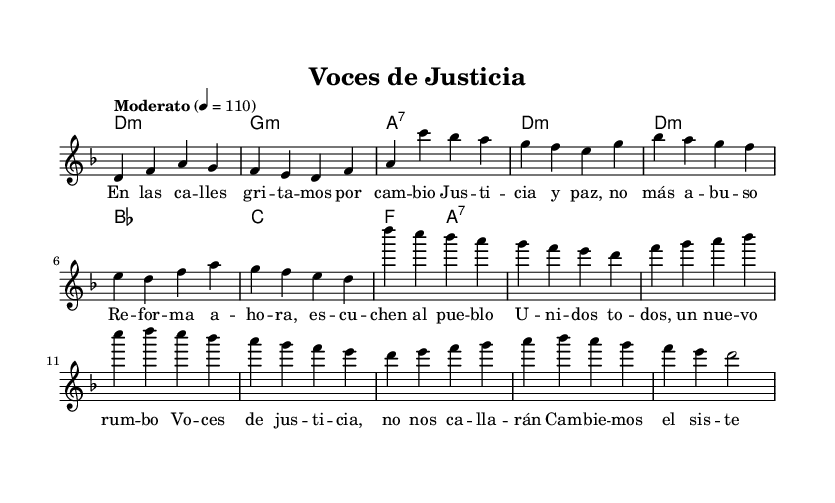What is the key signature of this music? The key signature is indicated at the beginning of the piece, which shows two flats, indicating that the piece is in D minor.
Answer: D minor What is the time signature of this music? The time signature is located right after the key signature, showing a 4/4 notation, which indicates that there are four beats in a measure.
Answer: 4/4 What is the tempo marking of this piece? The tempo notation appears in the score, which specifies "Moderato" at a speed of 4 = 110, indicating a moderate pace for the music.
Answer: Moderato How many measures are there in the verse? The verse consists of four lines of music, each containing four measures, so the total is 4 measures in the verse.
Answer: 16 What is the theme of the lyrics in the chorus? The chorus deals with social justice and calls for systemic change, as indicated by phrases like "Voices of justice" and "police reform."
Answer: Social justice Which chords are used in the chorus? The chords listed in the chord mode section for the chorus are D minor, B flat, C major, and A7, showing the harmonic structure of the chorus.
Answer: D minor, B flat, C major, A7 